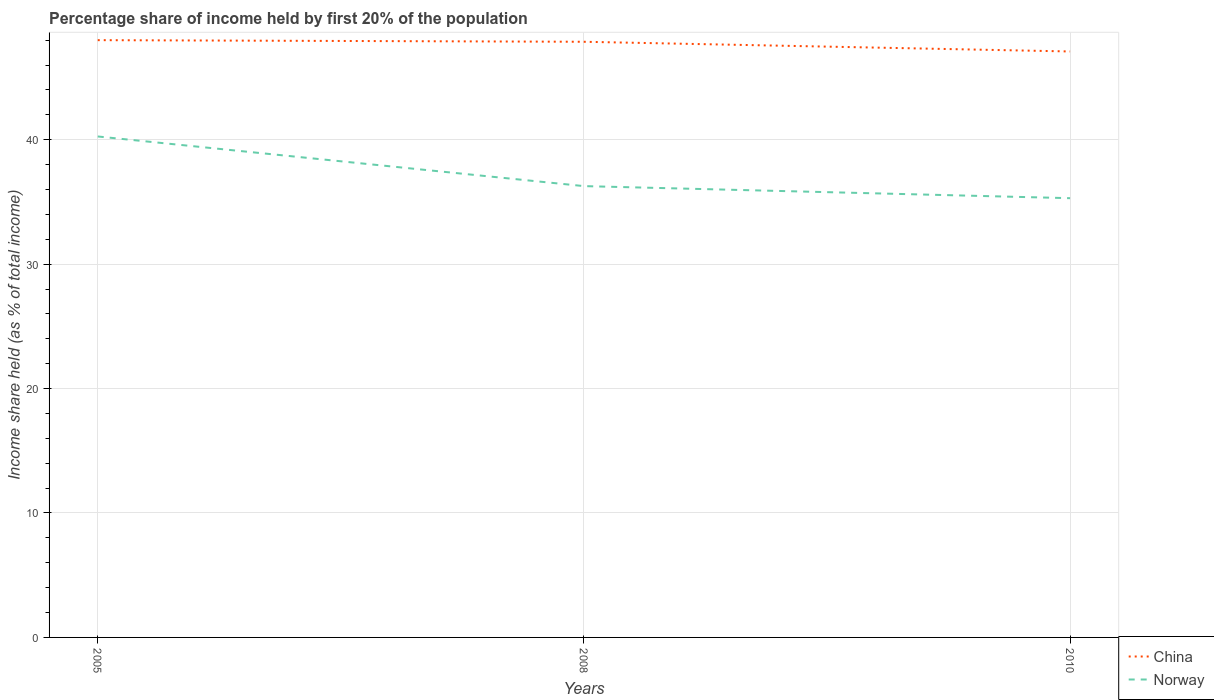How many different coloured lines are there?
Provide a succinct answer. 2. Does the line corresponding to Norway intersect with the line corresponding to China?
Offer a terse response. No. Across all years, what is the maximum share of income held by first 20% of the population in China?
Ensure brevity in your answer.  47.09. In which year was the share of income held by first 20% of the population in Norway maximum?
Your response must be concise. 2010. What is the total share of income held by first 20% of the population in China in the graph?
Offer a terse response. 0.78. What is the difference between the highest and the second highest share of income held by first 20% of the population in Norway?
Keep it short and to the point. 4.96. What is the difference between the highest and the lowest share of income held by first 20% of the population in Norway?
Offer a terse response. 1. Is the share of income held by first 20% of the population in China strictly greater than the share of income held by first 20% of the population in Norway over the years?
Make the answer very short. No. How many lines are there?
Keep it short and to the point. 2. What is the difference between two consecutive major ticks on the Y-axis?
Offer a very short reply. 10. Are the values on the major ticks of Y-axis written in scientific E-notation?
Provide a short and direct response. No. Does the graph contain grids?
Your response must be concise. Yes. Where does the legend appear in the graph?
Offer a terse response. Bottom right. How many legend labels are there?
Provide a succinct answer. 2. How are the legend labels stacked?
Offer a very short reply. Vertical. What is the title of the graph?
Make the answer very short. Percentage share of income held by first 20% of the population. Does "Sierra Leone" appear as one of the legend labels in the graph?
Give a very brief answer. No. What is the label or title of the Y-axis?
Your answer should be compact. Income share held (as % of total income). What is the Income share held (as % of total income) in Norway in 2005?
Keep it short and to the point. 40.26. What is the Income share held (as % of total income) in China in 2008?
Ensure brevity in your answer.  47.87. What is the Income share held (as % of total income) of Norway in 2008?
Keep it short and to the point. 36.27. What is the Income share held (as % of total income) of China in 2010?
Offer a terse response. 47.09. What is the Income share held (as % of total income) of Norway in 2010?
Offer a very short reply. 35.3. Across all years, what is the maximum Income share held (as % of total income) of China?
Keep it short and to the point. 48. Across all years, what is the maximum Income share held (as % of total income) in Norway?
Offer a very short reply. 40.26. Across all years, what is the minimum Income share held (as % of total income) in China?
Provide a succinct answer. 47.09. Across all years, what is the minimum Income share held (as % of total income) of Norway?
Make the answer very short. 35.3. What is the total Income share held (as % of total income) in China in the graph?
Provide a short and direct response. 142.96. What is the total Income share held (as % of total income) in Norway in the graph?
Ensure brevity in your answer.  111.83. What is the difference between the Income share held (as % of total income) of China in 2005 and that in 2008?
Your answer should be very brief. 0.13. What is the difference between the Income share held (as % of total income) in Norway in 2005 and that in 2008?
Your response must be concise. 3.99. What is the difference between the Income share held (as % of total income) of China in 2005 and that in 2010?
Your answer should be compact. 0.91. What is the difference between the Income share held (as % of total income) of Norway in 2005 and that in 2010?
Your answer should be compact. 4.96. What is the difference between the Income share held (as % of total income) in China in 2008 and that in 2010?
Make the answer very short. 0.78. What is the difference between the Income share held (as % of total income) of Norway in 2008 and that in 2010?
Offer a terse response. 0.97. What is the difference between the Income share held (as % of total income) of China in 2005 and the Income share held (as % of total income) of Norway in 2008?
Keep it short and to the point. 11.73. What is the difference between the Income share held (as % of total income) in China in 2005 and the Income share held (as % of total income) in Norway in 2010?
Make the answer very short. 12.7. What is the difference between the Income share held (as % of total income) of China in 2008 and the Income share held (as % of total income) of Norway in 2010?
Offer a terse response. 12.57. What is the average Income share held (as % of total income) in China per year?
Make the answer very short. 47.65. What is the average Income share held (as % of total income) in Norway per year?
Keep it short and to the point. 37.28. In the year 2005, what is the difference between the Income share held (as % of total income) in China and Income share held (as % of total income) in Norway?
Provide a short and direct response. 7.74. In the year 2008, what is the difference between the Income share held (as % of total income) in China and Income share held (as % of total income) in Norway?
Keep it short and to the point. 11.6. In the year 2010, what is the difference between the Income share held (as % of total income) in China and Income share held (as % of total income) in Norway?
Your response must be concise. 11.79. What is the ratio of the Income share held (as % of total income) in Norway in 2005 to that in 2008?
Offer a very short reply. 1.11. What is the ratio of the Income share held (as % of total income) in China in 2005 to that in 2010?
Provide a short and direct response. 1.02. What is the ratio of the Income share held (as % of total income) of Norway in 2005 to that in 2010?
Keep it short and to the point. 1.14. What is the ratio of the Income share held (as % of total income) in China in 2008 to that in 2010?
Ensure brevity in your answer.  1.02. What is the ratio of the Income share held (as % of total income) in Norway in 2008 to that in 2010?
Keep it short and to the point. 1.03. What is the difference between the highest and the second highest Income share held (as % of total income) in China?
Offer a terse response. 0.13. What is the difference between the highest and the second highest Income share held (as % of total income) in Norway?
Make the answer very short. 3.99. What is the difference between the highest and the lowest Income share held (as % of total income) in China?
Ensure brevity in your answer.  0.91. What is the difference between the highest and the lowest Income share held (as % of total income) in Norway?
Give a very brief answer. 4.96. 